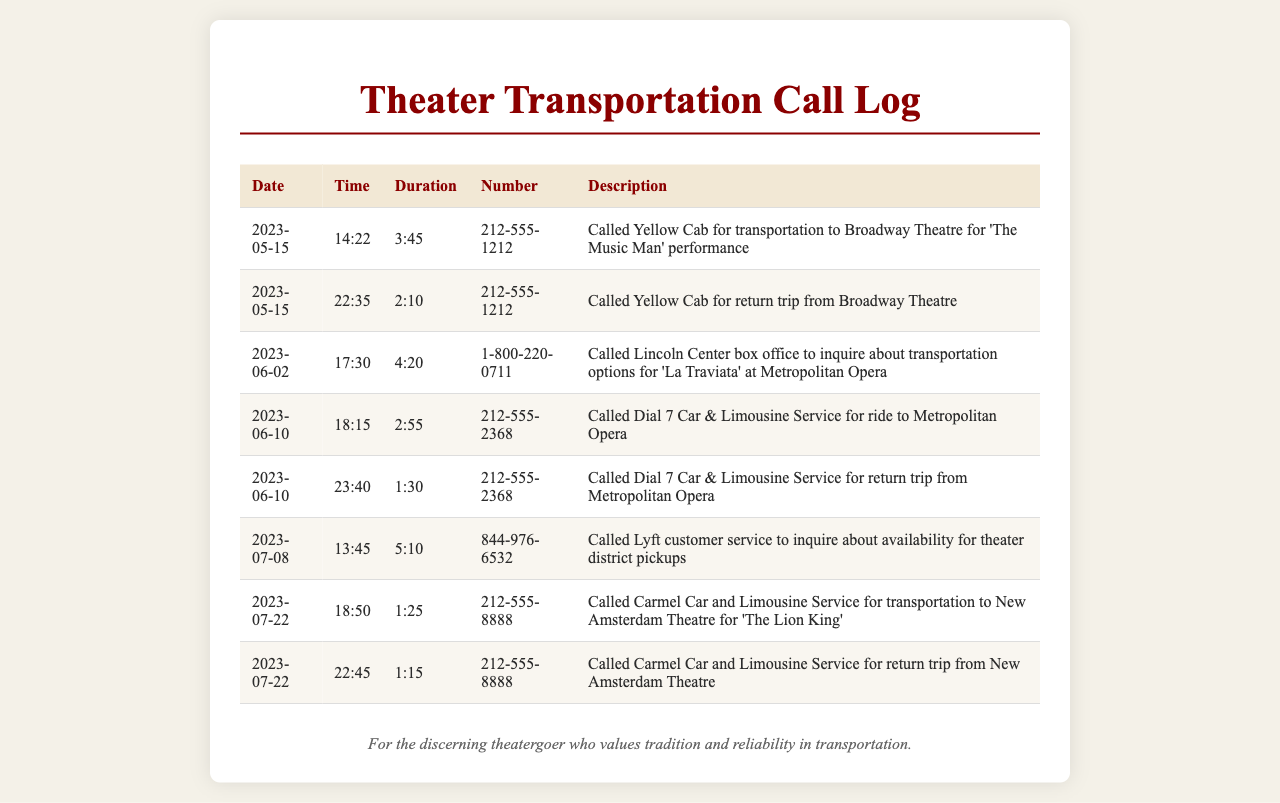what is the date of the first call? The first call occurred on May 15, 2023, which is the earliest date listed in the document.
Answer: May 15, 2023 what time was the call made for the return trip from Broadway Theatre? The return trip call was made at 22:35 on the same date as the first call, making it the second entry in the table.
Answer: 22:35 how long did the call to Lyft customer service last? The duration of the call to Lyft customer service is listed as 5:10 in the document, which refers to the time spent on that call.
Answer: 5:10 which service was used for transportation to 'The Lion King'? The call to arrange transportation for 'The Lion King' at New Amsterdam Theatre was made to Carmel Car and Limousine Service.
Answer: Carmel Car and Limousine Service what was the total duration of the calls for the Metropolitan Opera? The duration for the calls to the Metropolitan Opera totals 2:55 (to) + 1:30 (from) = 4:25.
Answer: 4:25 who was called for the inquiry about 'La Traviata' transportation options? The inquiry about transportation options for 'La Traviata' was made to the Lincoln Center box office at 1-800-220-0711.
Answer: Lincoln Center box office how many times were taxis called in the document? The taxi service, Yellow Cab, was called twice during the recorded entries in the document.
Answer: 2 when was the last recorded transportation call? The last recorded transportation call in the document was made on July 22, 2023.
Answer: July 22, 2023 